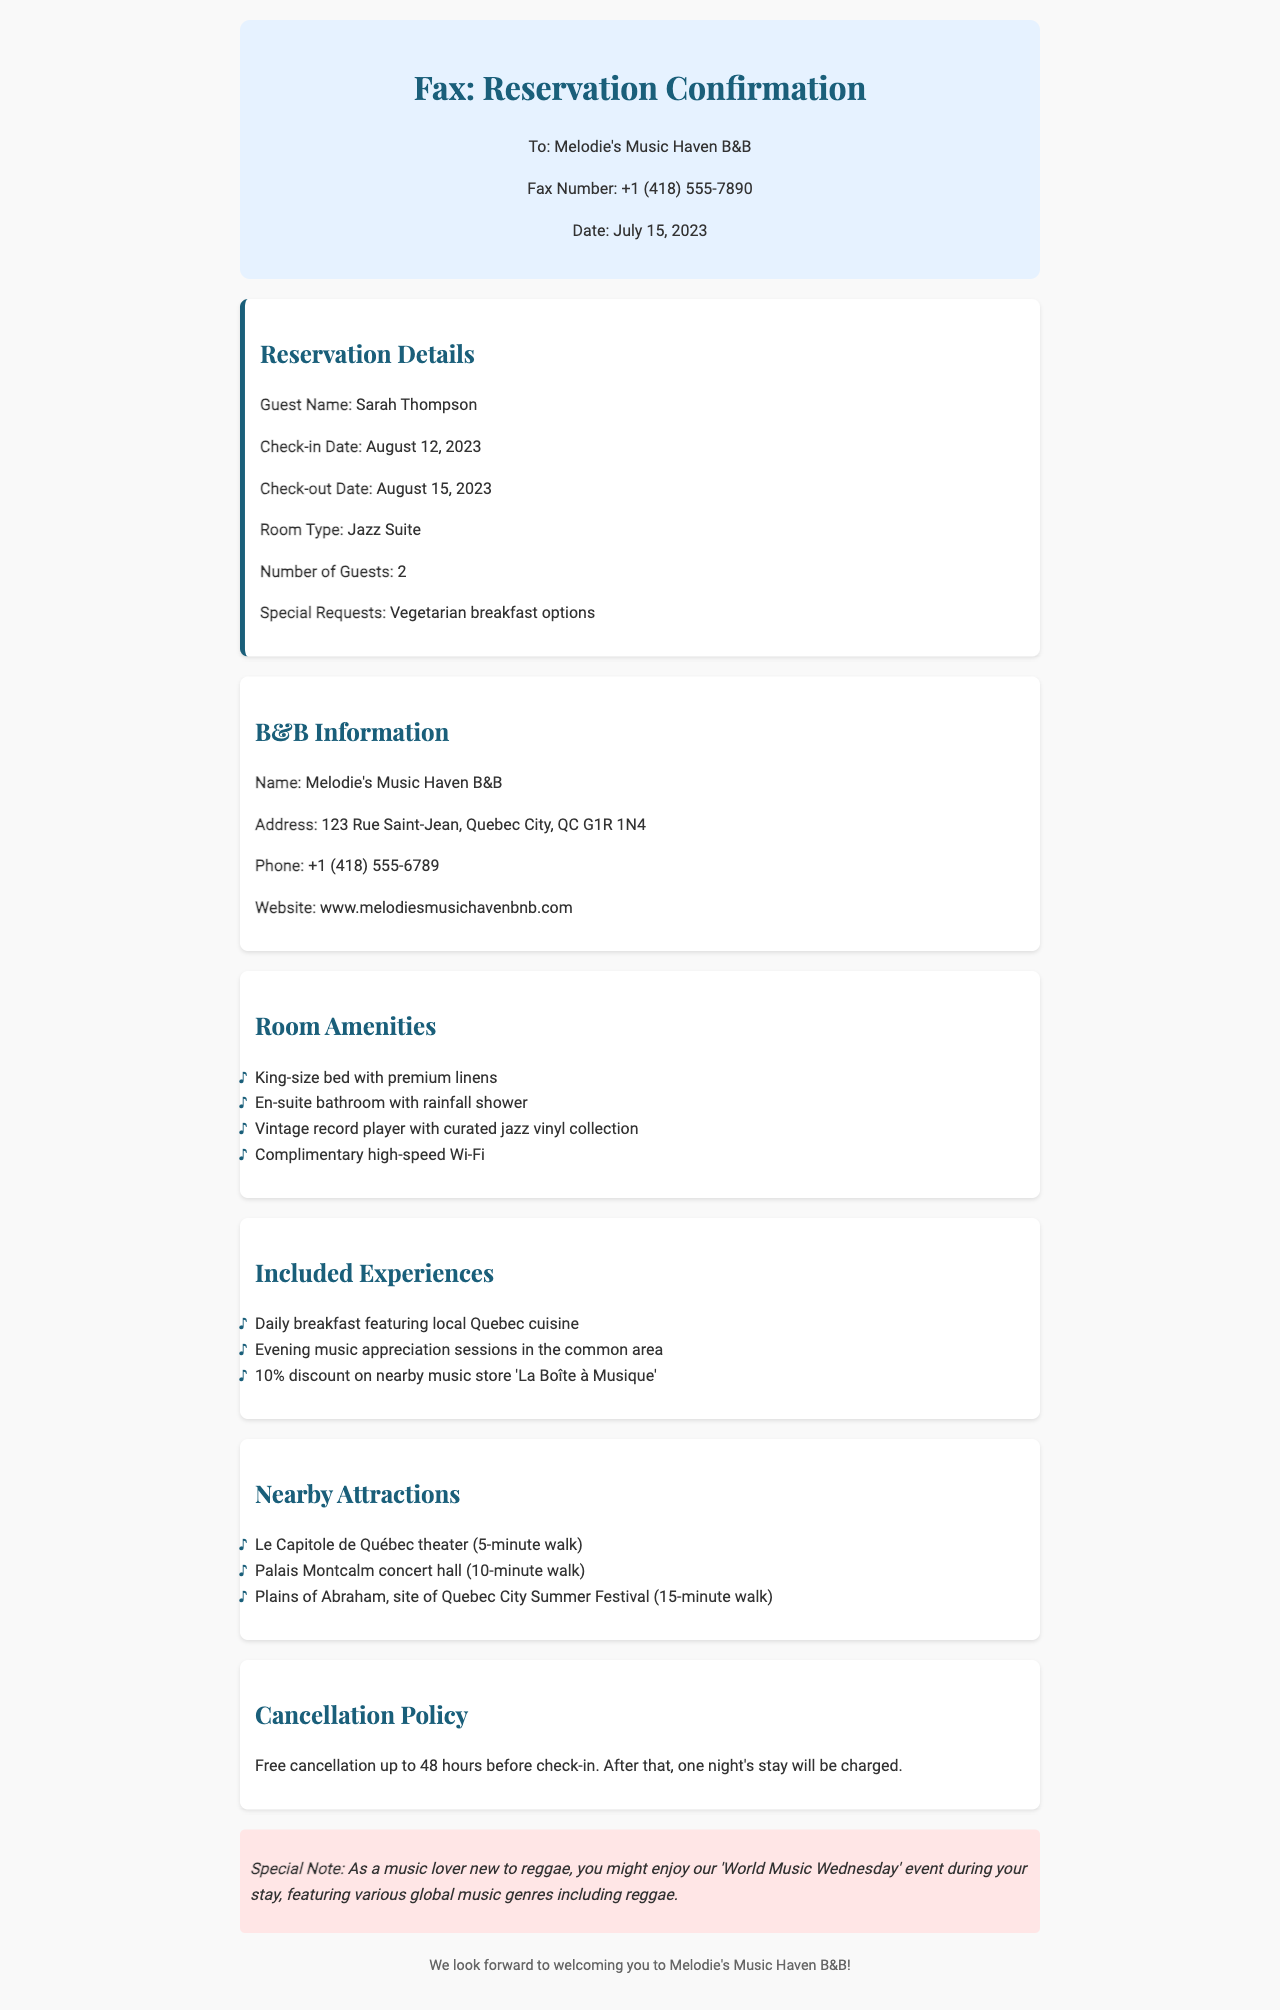What is the guest name? The guest name is noted in the reservation details section as "Sarah Thompson."
Answer: Sarah Thompson What are the check-in and check-out dates? The document specifies the check-in date as August 12, 2023, and the check-out date as August 15, 2023.
Answer: August 12, 2023 and August 15, 2023 What type of room is booked? The room type is mentioned in the reservation details as "Jazz Suite."
Answer: Jazz Suite What special requests did the guest make? The special requests noted in the document indicate that the guest requested "Vegetarian breakfast options."
Answer: Vegetarian breakfast options What is the cancellation policy? The cancellation policy states that free cancellation is allowed up to 48 hours before check-in, and charges apply afterward.
Answer: Free cancellation up to 48 hours before check-in How far is the Palais Montcalm concert hall from the B&B? The document provides the distance from the B&B to the Palais Montcalm concert hall as a "10-minute walk."
Answer: 10-minute walk What is included in the experiences? The included experiences feature several options, one of which is "Daily breakfast featuring local Quebec cuisine."
Answer: Daily breakfast featuring local Quebec cuisine What is the phone number for the music-themed B&B? The phone number listed in the B&B information section is "+1 (418) 555-6789."
Answer: +1 (418) 555-6789 What special event can a music lover enjoy during their stay? A special event mentioned for music lovers is "World Music Wednesday."
Answer: World Music Wednesday 